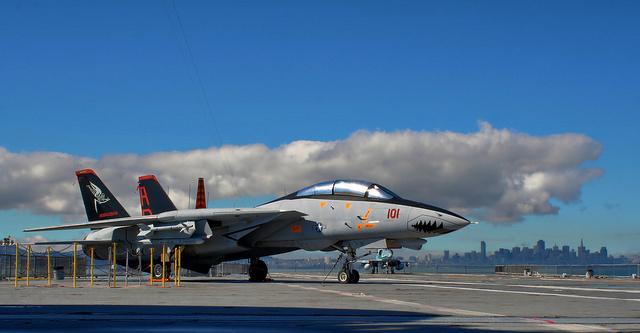Is the plane ready for takeoff?
Be succinct. Yes. Is this a commercial airplane?
Keep it brief. No. What is the color of clouds?
Concise answer only. Gray. 